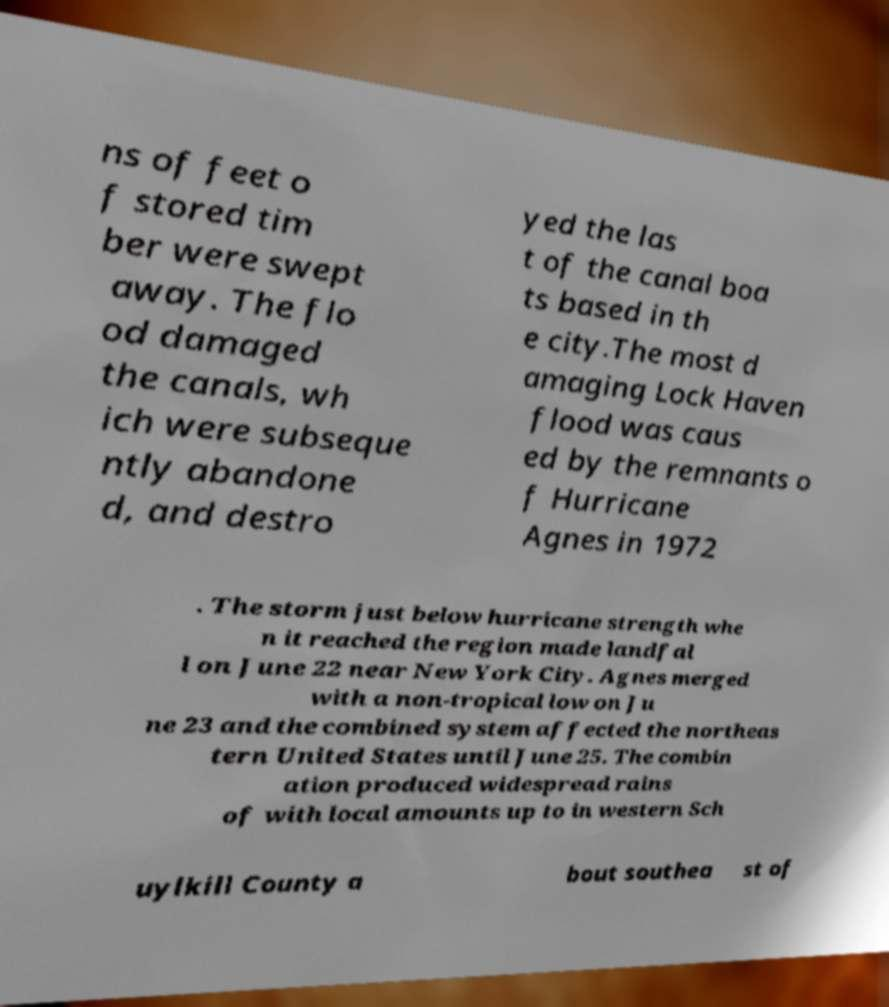What messages or text are displayed in this image? I need them in a readable, typed format. ns of feet o f stored tim ber were swept away. The flo od damaged the canals, wh ich were subseque ntly abandone d, and destro yed the las t of the canal boa ts based in th e city.The most d amaging Lock Haven flood was caus ed by the remnants o f Hurricane Agnes in 1972 . The storm just below hurricane strength whe n it reached the region made landfal l on June 22 near New York City. Agnes merged with a non-tropical low on Ju ne 23 and the combined system affected the northeas tern United States until June 25. The combin ation produced widespread rains of with local amounts up to in western Sch uylkill County a bout southea st of 